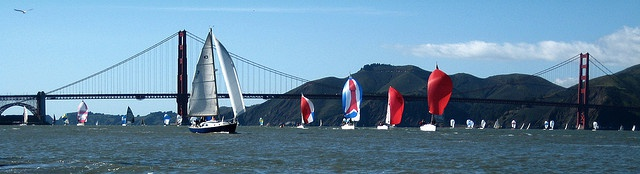Describe the objects in this image and their specific colors. I can see boat in lightblue, darkgray, white, and gray tones, boat in lightblue, black, blue, gray, and navy tones, boat in lightblue, maroon, brown, and white tones, boat in lightblue, white, blue, darkgray, and brown tones, and boat in lightblue, brown, white, and maroon tones in this image. 